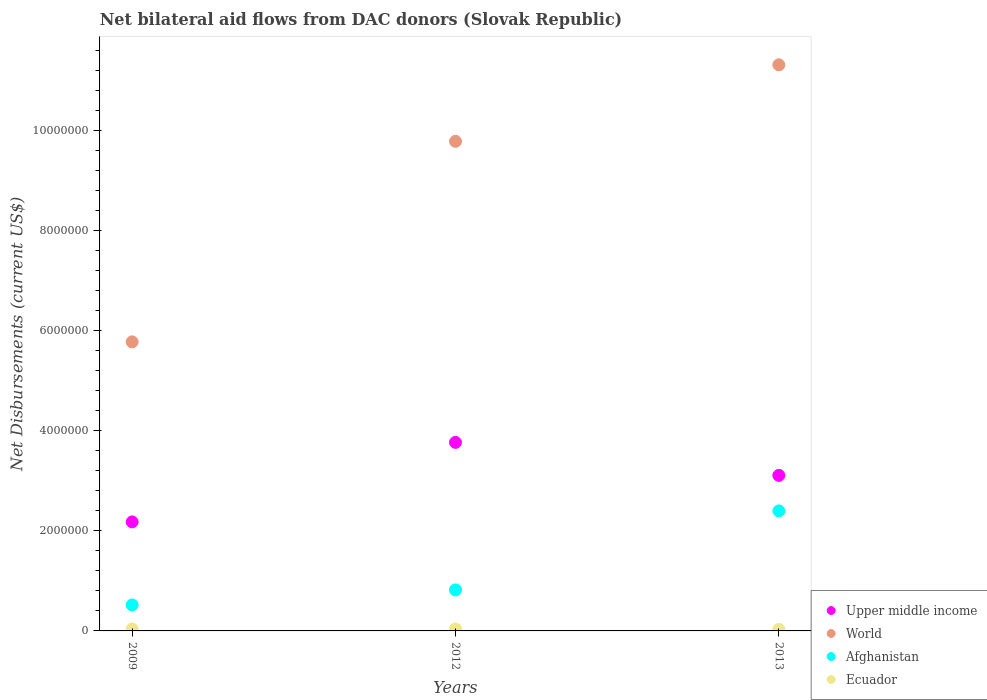How many different coloured dotlines are there?
Give a very brief answer. 4. Is the number of dotlines equal to the number of legend labels?
Offer a very short reply. Yes. What is the net bilateral aid flows in Ecuador in 2013?
Your response must be concise. 3.00e+04. Across all years, what is the maximum net bilateral aid flows in Afghanistan?
Provide a succinct answer. 2.40e+06. Across all years, what is the minimum net bilateral aid flows in World?
Your answer should be compact. 5.78e+06. In which year was the net bilateral aid flows in World maximum?
Your answer should be very brief. 2013. In which year was the net bilateral aid flows in World minimum?
Your answer should be compact. 2009. What is the total net bilateral aid flows in Upper middle income in the graph?
Offer a very short reply. 9.06e+06. What is the difference between the net bilateral aid flows in Afghanistan in 2012 and that in 2013?
Your answer should be very brief. -1.58e+06. What is the difference between the net bilateral aid flows in World in 2012 and the net bilateral aid flows in Upper middle income in 2009?
Provide a succinct answer. 7.61e+06. What is the average net bilateral aid flows in Ecuador per year?
Provide a succinct answer. 3.67e+04. In the year 2013, what is the difference between the net bilateral aid flows in Upper middle income and net bilateral aid flows in Afghanistan?
Your answer should be very brief. 7.10e+05. In how many years, is the net bilateral aid flows in Ecuador greater than 6400000 US$?
Make the answer very short. 0. What is the ratio of the net bilateral aid flows in Upper middle income in 2009 to that in 2013?
Provide a short and direct response. 0.7. Is the difference between the net bilateral aid flows in Upper middle income in 2009 and 2012 greater than the difference between the net bilateral aid flows in Afghanistan in 2009 and 2012?
Keep it short and to the point. No. What is the difference between the highest and the second highest net bilateral aid flows in Upper middle income?
Offer a terse response. 6.60e+05. What is the difference between the highest and the lowest net bilateral aid flows in World?
Give a very brief answer. 5.54e+06. In how many years, is the net bilateral aid flows in Upper middle income greater than the average net bilateral aid flows in Upper middle income taken over all years?
Ensure brevity in your answer.  2. Is the sum of the net bilateral aid flows in Ecuador in 2012 and 2013 greater than the maximum net bilateral aid flows in Afghanistan across all years?
Make the answer very short. No. Does the net bilateral aid flows in World monotonically increase over the years?
Your response must be concise. Yes. Is the net bilateral aid flows in Ecuador strictly less than the net bilateral aid flows in Upper middle income over the years?
Offer a terse response. Yes. How many years are there in the graph?
Provide a short and direct response. 3. What is the difference between two consecutive major ticks on the Y-axis?
Offer a terse response. 2.00e+06. Are the values on the major ticks of Y-axis written in scientific E-notation?
Your response must be concise. No. Where does the legend appear in the graph?
Your response must be concise. Bottom right. How many legend labels are there?
Offer a terse response. 4. What is the title of the graph?
Offer a very short reply. Net bilateral aid flows from DAC donors (Slovak Republic). What is the label or title of the Y-axis?
Your answer should be very brief. Net Disbursements (current US$). What is the Net Disbursements (current US$) in Upper middle income in 2009?
Give a very brief answer. 2.18e+06. What is the Net Disbursements (current US$) in World in 2009?
Your answer should be compact. 5.78e+06. What is the Net Disbursements (current US$) in Afghanistan in 2009?
Keep it short and to the point. 5.20e+05. What is the Net Disbursements (current US$) in Ecuador in 2009?
Offer a terse response. 4.00e+04. What is the Net Disbursements (current US$) of Upper middle income in 2012?
Give a very brief answer. 3.77e+06. What is the Net Disbursements (current US$) in World in 2012?
Make the answer very short. 9.79e+06. What is the Net Disbursements (current US$) of Afghanistan in 2012?
Your response must be concise. 8.20e+05. What is the Net Disbursements (current US$) of Ecuador in 2012?
Your answer should be very brief. 4.00e+04. What is the Net Disbursements (current US$) of Upper middle income in 2013?
Ensure brevity in your answer.  3.11e+06. What is the Net Disbursements (current US$) in World in 2013?
Your answer should be very brief. 1.13e+07. What is the Net Disbursements (current US$) of Afghanistan in 2013?
Offer a very short reply. 2.40e+06. Across all years, what is the maximum Net Disbursements (current US$) in Upper middle income?
Keep it short and to the point. 3.77e+06. Across all years, what is the maximum Net Disbursements (current US$) in World?
Your answer should be compact. 1.13e+07. Across all years, what is the maximum Net Disbursements (current US$) of Afghanistan?
Make the answer very short. 2.40e+06. Across all years, what is the minimum Net Disbursements (current US$) of Upper middle income?
Ensure brevity in your answer.  2.18e+06. Across all years, what is the minimum Net Disbursements (current US$) in World?
Provide a succinct answer. 5.78e+06. Across all years, what is the minimum Net Disbursements (current US$) of Afghanistan?
Provide a succinct answer. 5.20e+05. Across all years, what is the minimum Net Disbursements (current US$) in Ecuador?
Offer a very short reply. 3.00e+04. What is the total Net Disbursements (current US$) in Upper middle income in the graph?
Provide a short and direct response. 9.06e+06. What is the total Net Disbursements (current US$) of World in the graph?
Your answer should be compact. 2.69e+07. What is the total Net Disbursements (current US$) of Afghanistan in the graph?
Offer a terse response. 3.74e+06. What is the total Net Disbursements (current US$) in Ecuador in the graph?
Your answer should be compact. 1.10e+05. What is the difference between the Net Disbursements (current US$) of Upper middle income in 2009 and that in 2012?
Your response must be concise. -1.59e+06. What is the difference between the Net Disbursements (current US$) of World in 2009 and that in 2012?
Give a very brief answer. -4.01e+06. What is the difference between the Net Disbursements (current US$) in Ecuador in 2009 and that in 2012?
Your answer should be very brief. 0. What is the difference between the Net Disbursements (current US$) in Upper middle income in 2009 and that in 2013?
Provide a succinct answer. -9.30e+05. What is the difference between the Net Disbursements (current US$) of World in 2009 and that in 2013?
Give a very brief answer. -5.54e+06. What is the difference between the Net Disbursements (current US$) of Afghanistan in 2009 and that in 2013?
Give a very brief answer. -1.88e+06. What is the difference between the Net Disbursements (current US$) in World in 2012 and that in 2013?
Ensure brevity in your answer.  -1.53e+06. What is the difference between the Net Disbursements (current US$) of Afghanistan in 2012 and that in 2013?
Offer a very short reply. -1.58e+06. What is the difference between the Net Disbursements (current US$) in Ecuador in 2012 and that in 2013?
Make the answer very short. 10000. What is the difference between the Net Disbursements (current US$) of Upper middle income in 2009 and the Net Disbursements (current US$) of World in 2012?
Offer a terse response. -7.61e+06. What is the difference between the Net Disbursements (current US$) of Upper middle income in 2009 and the Net Disbursements (current US$) of Afghanistan in 2012?
Provide a succinct answer. 1.36e+06. What is the difference between the Net Disbursements (current US$) of Upper middle income in 2009 and the Net Disbursements (current US$) of Ecuador in 2012?
Offer a very short reply. 2.14e+06. What is the difference between the Net Disbursements (current US$) in World in 2009 and the Net Disbursements (current US$) in Afghanistan in 2012?
Your response must be concise. 4.96e+06. What is the difference between the Net Disbursements (current US$) in World in 2009 and the Net Disbursements (current US$) in Ecuador in 2012?
Provide a short and direct response. 5.74e+06. What is the difference between the Net Disbursements (current US$) in Upper middle income in 2009 and the Net Disbursements (current US$) in World in 2013?
Provide a succinct answer. -9.14e+06. What is the difference between the Net Disbursements (current US$) in Upper middle income in 2009 and the Net Disbursements (current US$) in Afghanistan in 2013?
Your answer should be very brief. -2.20e+05. What is the difference between the Net Disbursements (current US$) in Upper middle income in 2009 and the Net Disbursements (current US$) in Ecuador in 2013?
Provide a succinct answer. 2.15e+06. What is the difference between the Net Disbursements (current US$) of World in 2009 and the Net Disbursements (current US$) of Afghanistan in 2013?
Your answer should be compact. 3.38e+06. What is the difference between the Net Disbursements (current US$) in World in 2009 and the Net Disbursements (current US$) in Ecuador in 2013?
Offer a very short reply. 5.75e+06. What is the difference between the Net Disbursements (current US$) of Upper middle income in 2012 and the Net Disbursements (current US$) of World in 2013?
Keep it short and to the point. -7.55e+06. What is the difference between the Net Disbursements (current US$) in Upper middle income in 2012 and the Net Disbursements (current US$) in Afghanistan in 2013?
Provide a short and direct response. 1.37e+06. What is the difference between the Net Disbursements (current US$) of Upper middle income in 2012 and the Net Disbursements (current US$) of Ecuador in 2013?
Your answer should be compact. 3.74e+06. What is the difference between the Net Disbursements (current US$) of World in 2012 and the Net Disbursements (current US$) of Afghanistan in 2013?
Offer a terse response. 7.39e+06. What is the difference between the Net Disbursements (current US$) in World in 2012 and the Net Disbursements (current US$) in Ecuador in 2013?
Your answer should be very brief. 9.76e+06. What is the difference between the Net Disbursements (current US$) of Afghanistan in 2012 and the Net Disbursements (current US$) of Ecuador in 2013?
Ensure brevity in your answer.  7.90e+05. What is the average Net Disbursements (current US$) in Upper middle income per year?
Provide a short and direct response. 3.02e+06. What is the average Net Disbursements (current US$) of World per year?
Ensure brevity in your answer.  8.96e+06. What is the average Net Disbursements (current US$) in Afghanistan per year?
Ensure brevity in your answer.  1.25e+06. What is the average Net Disbursements (current US$) in Ecuador per year?
Your answer should be compact. 3.67e+04. In the year 2009, what is the difference between the Net Disbursements (current US$) of Upper middle income and Net Disbursements (current US$) of World?
Your answer should be compact. -3.60e+06. In the year 2009, what is the difference between the Net Disbursements (current US$) of Upper middle income and Net Disbursements (current US$) of Afghanistan?
Offer a very short reply. 1.66e+06. In the year 2009, what is the difference between the Net Disbursements (current US$) of Upper middle income and Net Disbursements (current US$) of Ecuador?
Your answer should be compact. 2.14e+06. In the year 2009, what is the difference between the Net Disbursements (current US$) of World and Net Disbursements (current US$) of Afghanistan?
Provide a short and direct response. 5.26e+06. In the year 2009, what is the difference between the Net Disbursements (current US$) of World and Net Disbursements (current US$) of Ecuador?
Offer a very short reply. 5.74e+06. In the year 2012, what is the difference between the Net Disbursements (current US$) of Upper middle income and Net Disbursements (current US$) of World?
Make the answer very short. -6.02e+06. In the year 2012, what is the difference between the Net Disbursements (current US$) in Upper middle income and Net Disbursements (current US$) in Afghanistan?
Provide a short and direct response. 2.95e+06. In the year 2012, what is the difference between the Net Disbursements (current US$) of Upper middle income and Net Disbursements (current US$) of Ecuador?
Make the answer very short. 3.73e+06. In the year 2012, what is the difference between the Net Disbursements (current US$) of World and Net Disbursements (current US$) of Afghanistan?
Give a very brief answer. 8.97e+06. In the year 2012, what is the difference between the Net Disbursements (current US$) in World and Net Disbursements (current US$) in Ecuador?
Keep it short and to the point. 9.75e+06. In the year 2012, what is the difference between the Net Disbursements (current US$) in Afghanistan and Net Disbursements (current US$) in Ecuador?
Your answer should be compact. 7.80e+05. In the year 2013, what is the difference between the Net Disbursements (current US$) in Upper middle income and Net Disbursements (current US$) in World?
Your response must be concise. -8.21e+06. In the year 2013, what is the difference between the Net Disbursements (current US$) of Upper middle income and Net Disbursements (current US$) of Afghanistan?
Provide a short and direct response. 7.10e+05. In the year 2013, what is the difference between the Net Disbursements (current US$) in Upper middle income and Net Disbursements (current US$) in Ecuador?
Provide a succinct answer. 3.08e+06. In the year 2013, what is the difference between the Net Disbursements (current US$) of World and Net Disbursements (current US$) of Afghanistan?
Ensure brevity in your answer.  8.92e+06. In the year 2013, what is the difference between the Net Disbursements (current US$) of World and Net Disbursements (current US$) of Ecuador?
Make the answer very short. 1.13e+07. In the year 2013, what is the difference between the Net Disbursements (current US$) of Afghanistan and Net Disbursements (current US$) of Ecuador?
Offer a terse response. 2.37e+06. What is the ratio of the Net Disbursements (current US$) in Upper middle income in 2009 to that in 2012?
Your answer should be very brief. 0.58. What is the ratio of the Net Disbursements (current US$) in World in 2009 to that in 2012?
Give a very brief answer. 0.59. What is the ratio of the Net Disbursements (current US$) in Afghanistan in 2009 to that in 2012?
Keep it short and to the point. 0.63. What is the ratio of the Net Disbursements (current US$) of Upper middle income in 2009 to that in 2013?
Your response must be concise. 0.7. What is the ratio of the Net Disbursements (current US$) in World in 2009 to that in 2013?
Offer a terse response. 0.51. What is the ratio of the Net Disbursements (current US$) of Afghanistan in 2009 to that in 2013?
Your response must be concise. 0.22. What is the ratio of the Net Disbursements (current US$) in Ecuador in 2009 to that in 2013?
Your answer should be compact. 1.33. What is the ratio of the Net Disbursements (current US$) in Upper middle income in 2012 to that in 2013?
Ensure brevity in your answer.  1.21. What is the ratio of the Net Disbursements (current US$) in World in 2012 to that in 2013?
Offer a very short reply. 0.86. What is the ratio of the Net Disbursements (current US$) of Afghanistan in 2012 to that in 2013?
Your response must be concise. 0.34. What is the ratio of the Net Disbursements (current US$) in Ecuador in 2012 to that in 2013?
Your answer should be very brief. 1.33. What is the difference between the highest and the second highest Net Disbursements (current US$) of Upper middle income?
Ensure brevity in your answer.  6.60e+05. What is the difference between the highest and the second highest Net Disbursements (current US$) in World?
Ensure brevity in your answer.  1.53e+06. What is the difference between the highest and the second highest Net Disbursements (current US$) of Afghanistan?
Provide a succinct answer. 1.58e+06. What is the difference between the highest and the lowest Net Disbursements (current US$) of Upper middle income?
Offer a very short reply. 1.59e+06. What is the difference between the highest and the lowest Net Disbursements (current US$) in World?
Keep it short and to the point. 5.54e+06. What is the difference between the highest and the lowest Net Disbursements (current US$) of Afghanistan?
Keep it short and to the point. 1.88e+06. 